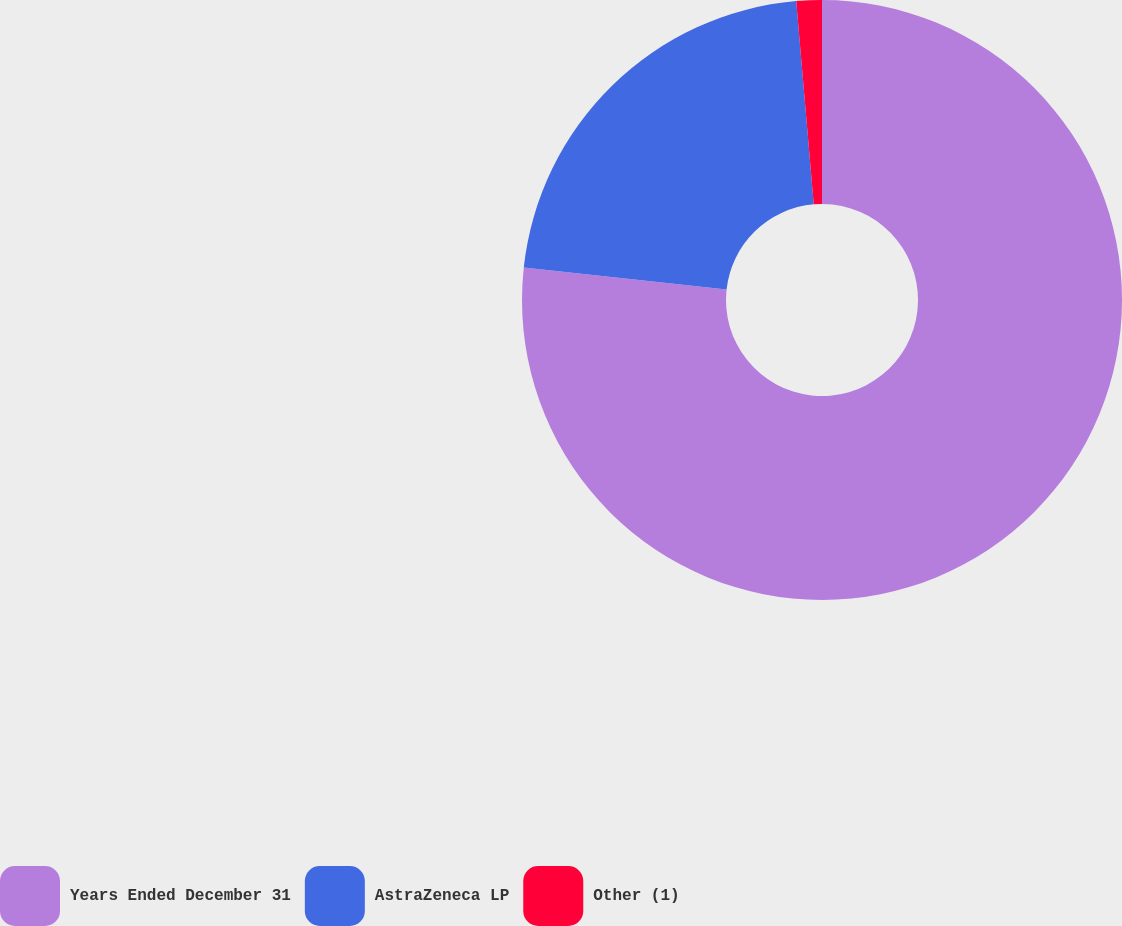Convert chart. <chart><loc_0><loc_0><loc_500><loc_500><pie_chart><fcel>Years Ended December 31<fcel>AstraZeneca LP<fcel>Other (1)<nl><fcel>76.73%<fcel>21.9%<fcel>1.37%<nl></chart> 